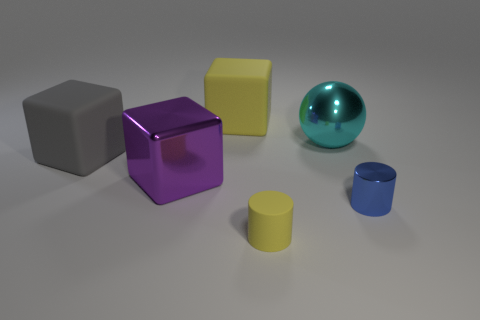Are there any rubber objects that have the same color as the small matte cylinder?
Offer a very short reply. Yes. What size is the block that is the same color as the tiny rubber cylinder?
Ensure brevity in your answer.  Large. Do the rubber thing to the right of the yellow rubber block and the thing behind the cyan shiny sphere have the same color?
Make the answer very short. Yes. The large object that is the same color as the matte cylinder is what shape?
Ensure brevity in your answer.  Cube. Are there any other things that are the same color as the small rubber cylinder?
Provide a succinct answer. Yes. Is the color of the large shiny cube the same as the sphere?
Your response must be concise. No. How many other objects have the same color as the small matte thing?
Provide a short and direct response. 1. Are there more yellow spheres than gray objects?
Give a very brief answer. No. There is a object that is both behind the big purple metallic object and to the left of the big yellow block; how big is it?
Your response must be concise. Large. Do the block that is behind the cyan shiny thing and the yellow object to the right of the large yellow cube have the same material?
Offer a very short reply. Yes. 